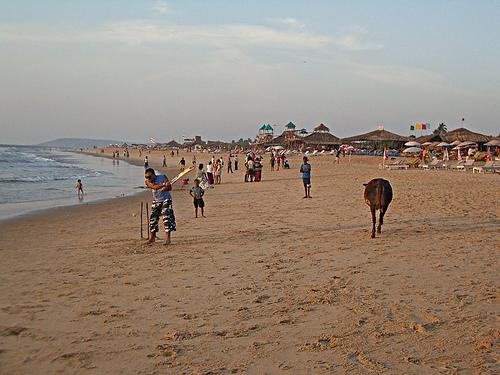What animals are in the water on the beach?
Write a very short answer. Cow. Is the beach crowded?
Concise answer only. Yes. What are they throwing?
Write a very short answer. Ball. What animal is behind the man?
Answer briefly. Cow. Does the activity in the photo look family friendly?
Be succinct. Yes. What large thing is walking on the sand?
Quick response, please. Horse. Is this a cow farm?
Answer briefly. No. What are the people wearing?
Write a very short answer. Clothes. How many horses?
Give a very brief answer. 1. How many brown horses are there?
Keep it brief. 1. What type of animal is this?
Short answer required. Cow. What color umbrella can be seen in the background?
Short answer required. White. Is this a wild horse?
Concise answer only. No. Where was this picture taken?
Short answer required. Beach. What is on the far background on the left?
Give a very brief answer. Mountain. What is the child catching?
Be succinct. Ball. Are most of the people in this photo having fun?
Answer briefly. Yes. 